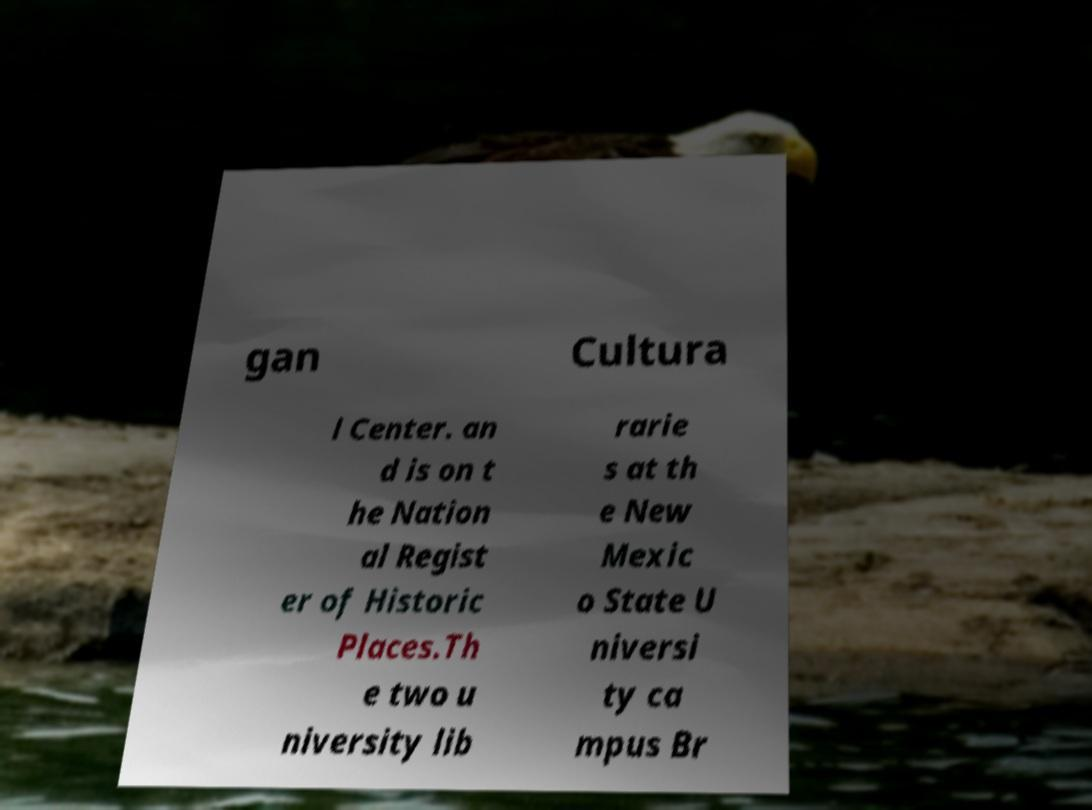Can you read and provide the text displayed in the image?This photo seems to have some interesting text. Can you extract and type it out for me? gan Cultura l Center. an d is on t he Nation al Regist er of Historic Places.Th e two u niversity lib rarie s at th e New Mexic o State U niversi ty ca mpus Br 